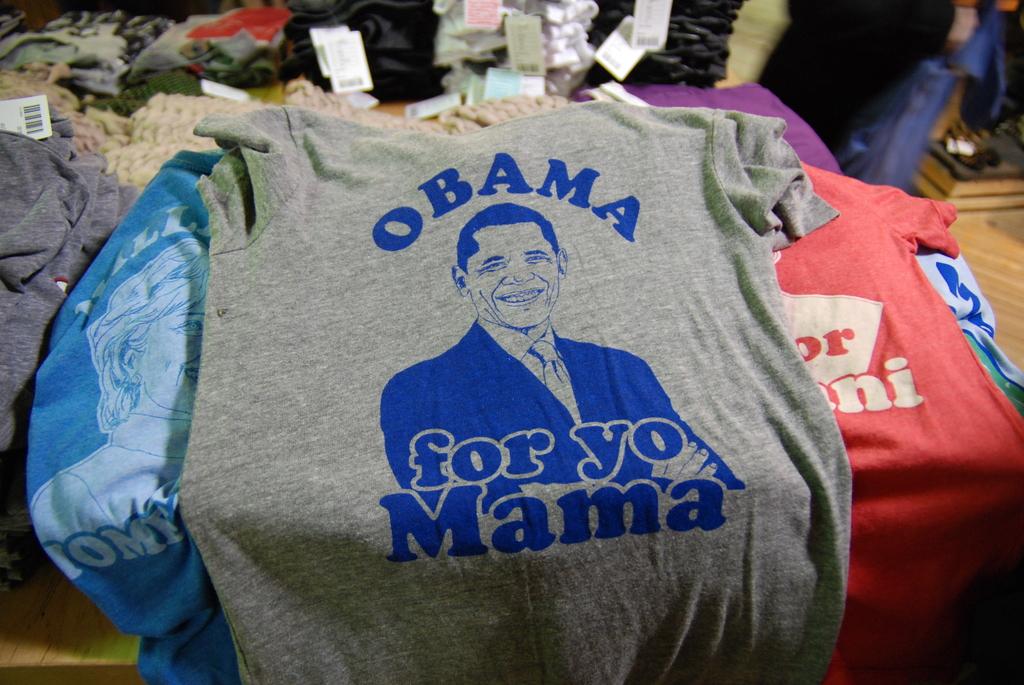What is the last word on the shirt?
Keep it short and to the point. Mama. 